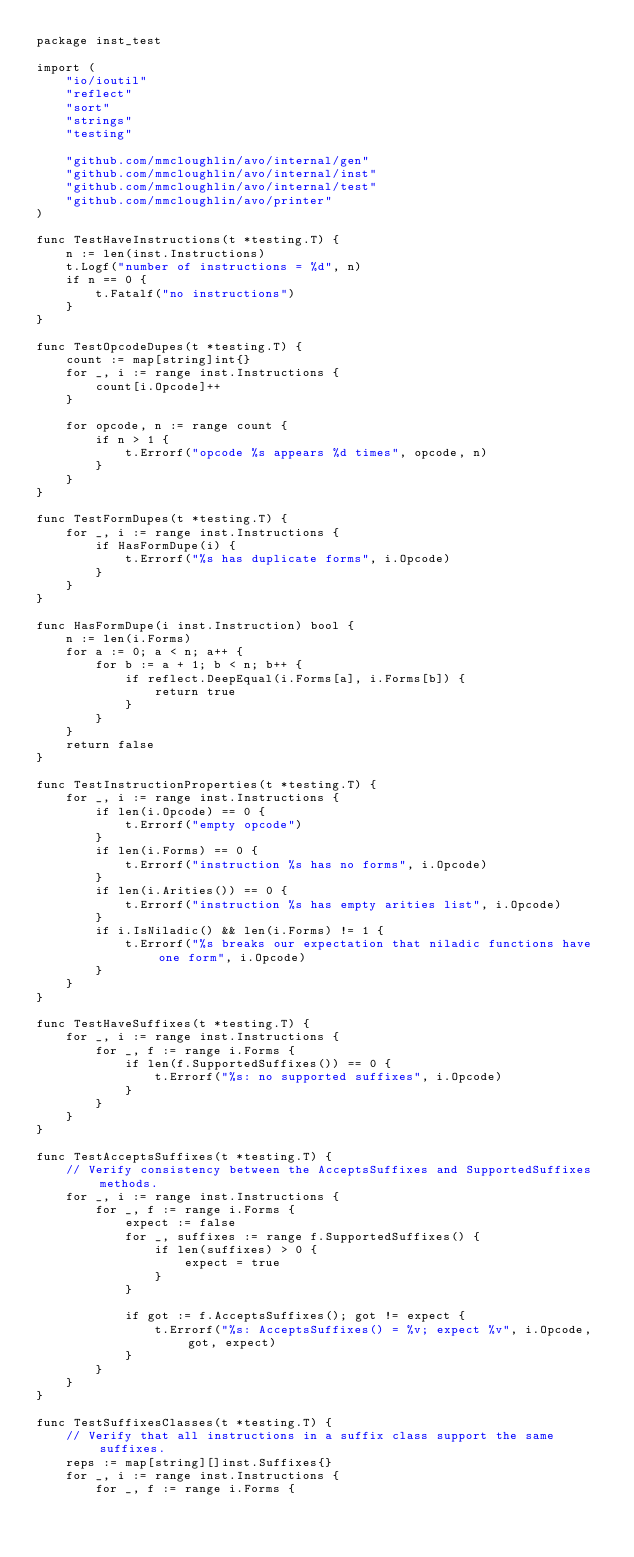<code> <loc_0><loc_0><loc_500><loc_500><_Go_>package inst_test

import (
	"io/ioutil"
	"reflect"
	"sort"
	"strings"
	"testing"

	"github.com/mmcloughlin/avo/internal/gen"
	"github.com/mmcloughlin/avo/internal/inst"
	"github.com/mmcloughlin/avo/internal/test"
	"github.com/mmcloughlin/avo/printer"
)

func TestHaveInstructions(t *testing.T) {
	n := len(inst.Instructions)
	t.Logf("number of instructions = %d", n)
	if n == 0 {
		t.Fatalf("no instructions")
	}
}

func TestOpcodeDupes(t *testing.T) {
	count := map[string]int{}
	for _, i := range inst.Instructions {
		count[i.Opcode]++
	}

	for opcode, n := range count {
		if n > 1 {
			t.Errorf("opcode %s appears %d times", opcode, n)
		}
	}
}

func TestFormDupes(t *testing.T) {
	for _, i := range inst.Instructions {
		if HasFormDupe(i) {
			t.Errorf("%s has duplicate forms", i.Opcode)
		}
	}
}

func HasFormDupe(i inst.Instruction) bool {
	n := len(i.Forms)
	for a := 0; a < n; a++ {
		for b := a + 1; b < n; b++ {
			if reflect.DeepEqual(i.Forms[a], i.Forms[b]) {
				return true
			}
		}
	}
	return false
}

func TestInstructionProperties(t *testing.T) {
	for _, i := range inst.Instructions {
		if len(i.Opcode) == 0 {
			t.Errorf("empty opcode")
		}
		if len(i.Forms) == 0 {
			t.Errorf("instruction %s has no forms", i.Opcode)
		}
		if len(i.Arities()) == 0 {
			t.Errorf("instruction %s has empty arities list", i.Opcode)
		}
		if i.IsNiladic() && len(i.Forms) != 1 {
			t.Errorf("%s breaks our expectation that niladic functions have one form", i.Opcode)
		}
	}
}

func TestHaveSuffixes(t *testing.T) {
	for _, i := range inst.Instructions {
		for _, f := range i.Forms {
			if len(f.SupportedSuffixes()) == 0 {
				t.Errorf("%s: no supported suffixes", i.Opcode)
			}
		}
	}
}

func TestAcceptsSuffixes(t *testing.T) {
	// Verify consistency between the AcceptsSuffixes and SupportedSuffixes methods.
	for _, i := range inst.Instructions {
		for _, f := range i.Forms {
			expect := false
			for _, suffixes := range f.SupportedSuffixes() {
				if len(suffixes) > 0 {
					expect = true
				}
			}

			if got := f.AcceptsSuffixes(); got != expect {
				t.Errorf("%s: AcceptsSuffixes() = %v; expect %v", i.Opcode, got, expect)
			}
		}
	}
}

func TestSuffixesClasses(t *testing.T) {
	// Verify that all instructions in a suffix class support the same suffixes.
	reps := map[string][]inst.Suffixes{}
	for _, i := range inst.Instructions {
		for _, f := range i.Forms {</code> 